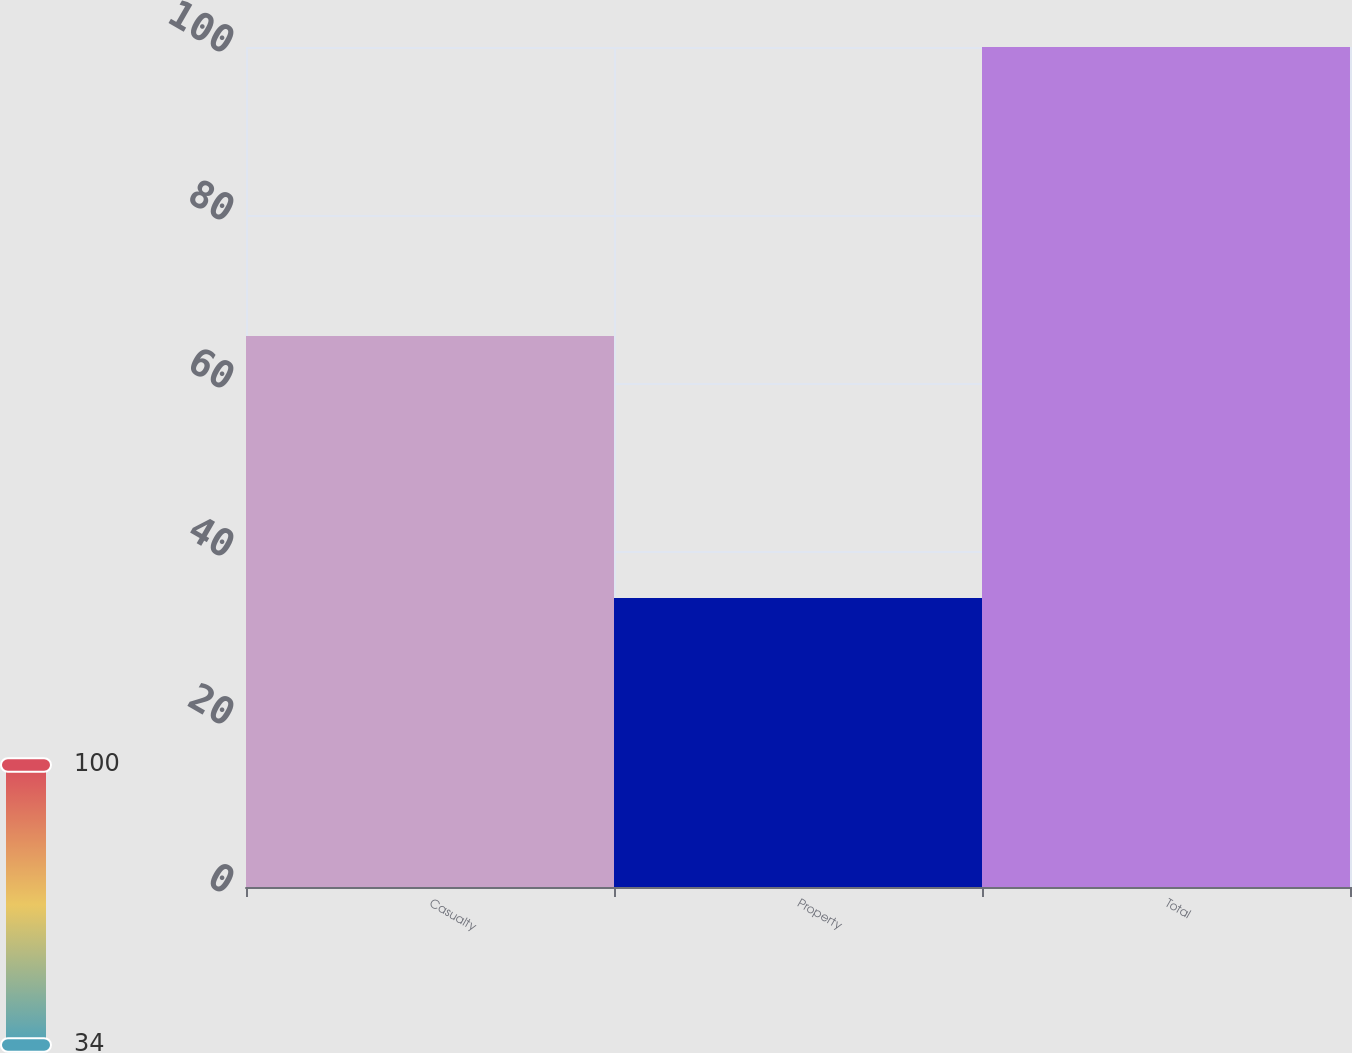<chart> <loc_0><loc_0><loc_500><loc_500><bar_chart><fcel>Casualty<fcel>Property<fcel>Total<nl><fcel>65.6<fcel>34.4<fcel>100<nl></chart> 